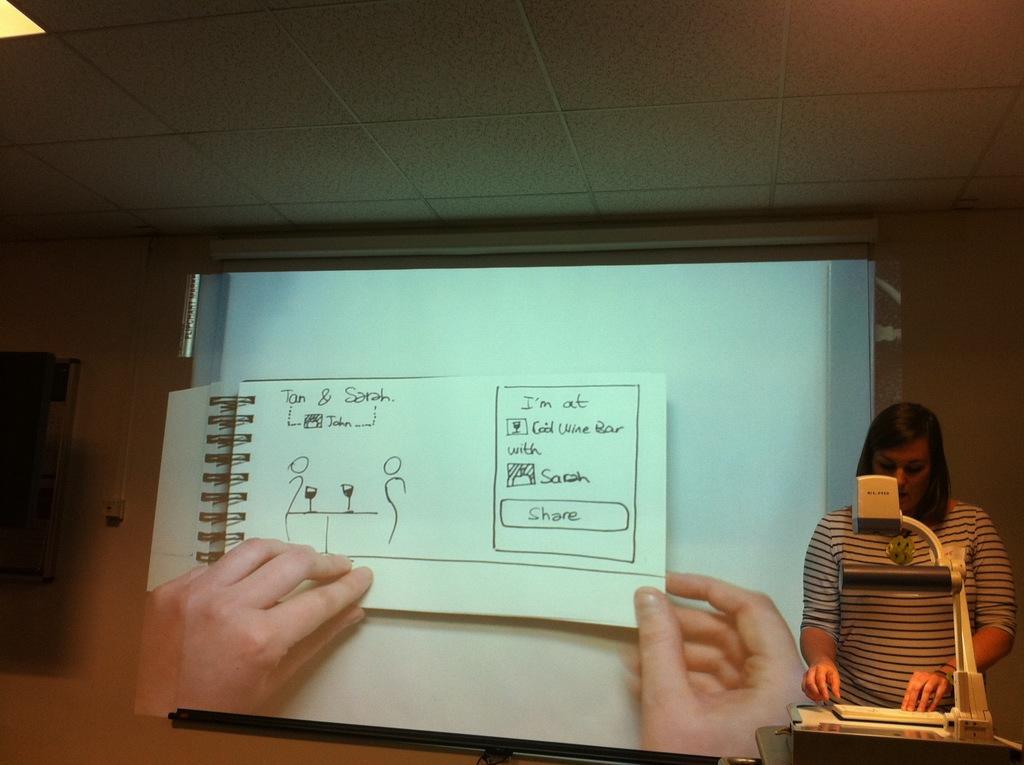Describe this image in one or two sentences. In the center of the picture there is a projector screen. On the right there is a woman and there are podium, book and an object. On the left there is an object. At the top it is ceiling. At the top left there is a light. 